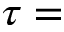<formula> <loc_0><loc_0><loc_500><loc_500>\tau =</formula> 